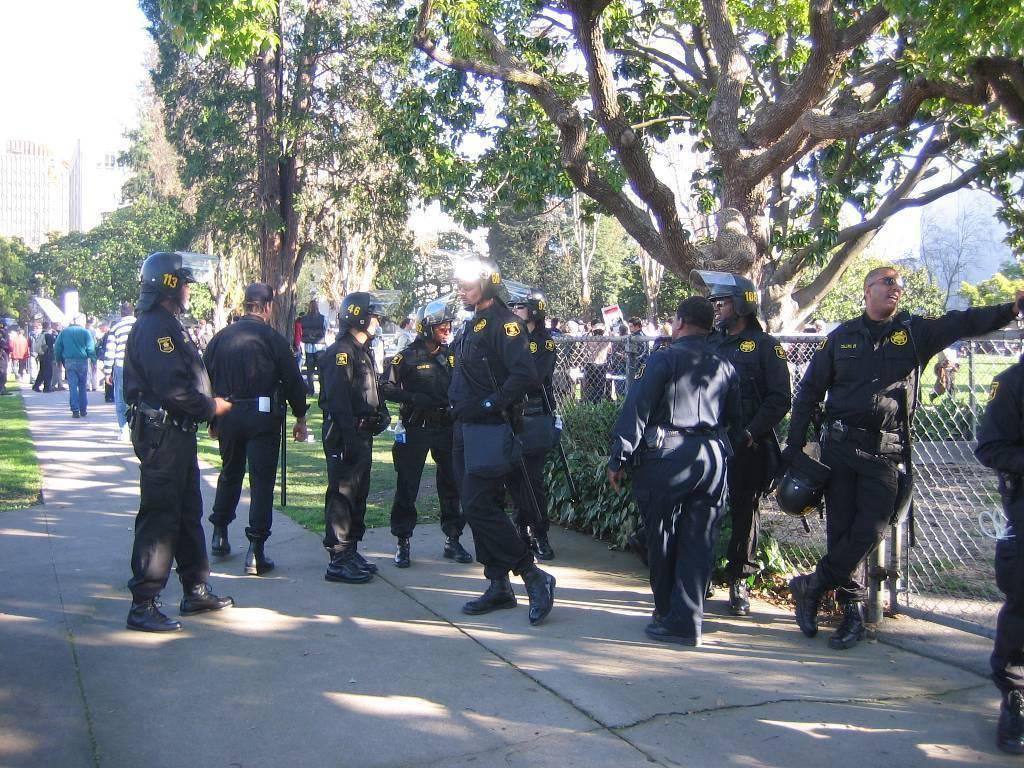Please provide a concise description of this image. This is an outside view. Here I can see few people wearing uniform, helmets on their heads, bags and standing on the ground. In the background, I can see a crowd of people and there are many trees. On the right side there is a net fencing. On the left side there are few buildings. At the top of the image I can see the sky. 